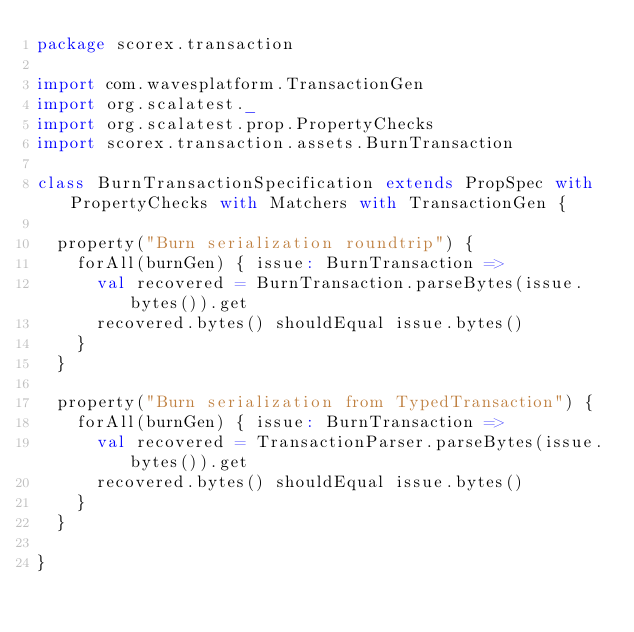Convert code to text. <code><loc_0><loc_0><loc_500><loc_500><_Scala_>package scorex.transaction

import com.wavesplatform.TransactionGen
import org.scalatest._
import org.scalatest.prop.PropertyChecks
import scorex.transaction.assets.BurnTransaction

class BurnTransactionSpecification extends PropSpec with PropertyChecks with Matchers with TransactionGen {

  property("Burn serialization roundtrip") {
    forAll(burnGen) { issue: BurnTransaction =>
      val recovered = BurnTransaction.parseBytes(issue.bytes()).get
      recovered.bytes() shouldEqual issue.bytes()
    }
  }

  property("Burn serialization from TypedTransaction") {
    forAll(burnGen) { issue: BurnTransaction =>
      val recovered = TransactionParser.parseBytes(issue.bytes()).get
      recovered.bytes() shouldEqual issue.bytes()
    }
  }

}
</code> 